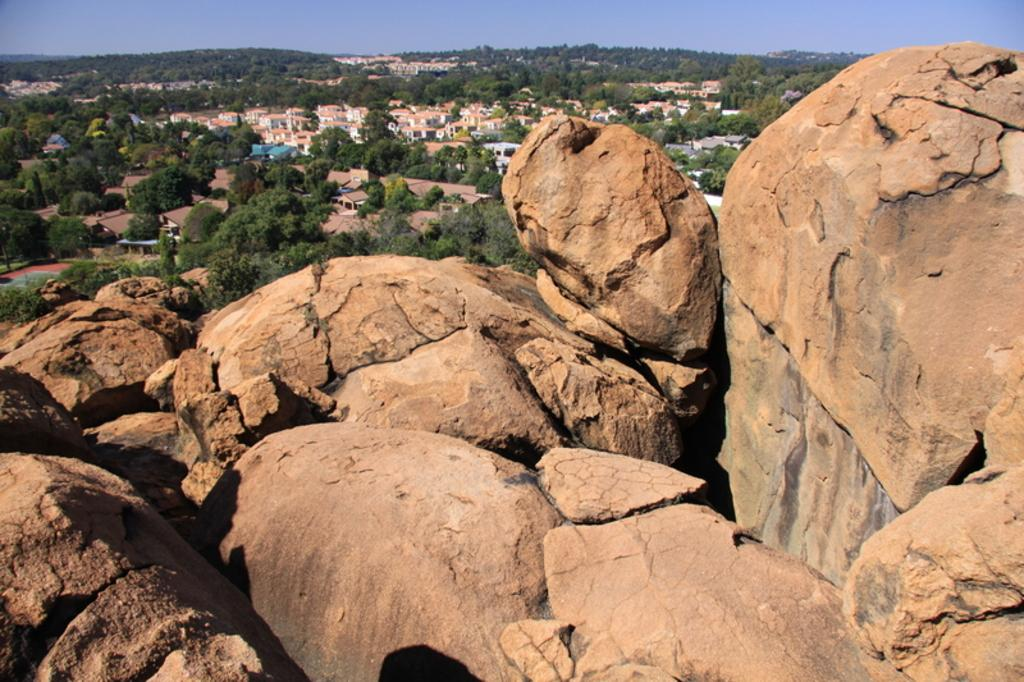What can be seen in the background of the image? The sky is visible in the background of the image. What type of structures are present in the image? There are buildings in the image. What type of vegetation is present in the image? Trees are present in the image. What part of the buildings can be seen in the image? Rooftops are visible in the image. What type of natural landform is present in the image? Mountains are present in the image. What type of bread can be seen on top of the mountain in the image? There is no bread present in the image, and no bread is visible on top of the mountain. 